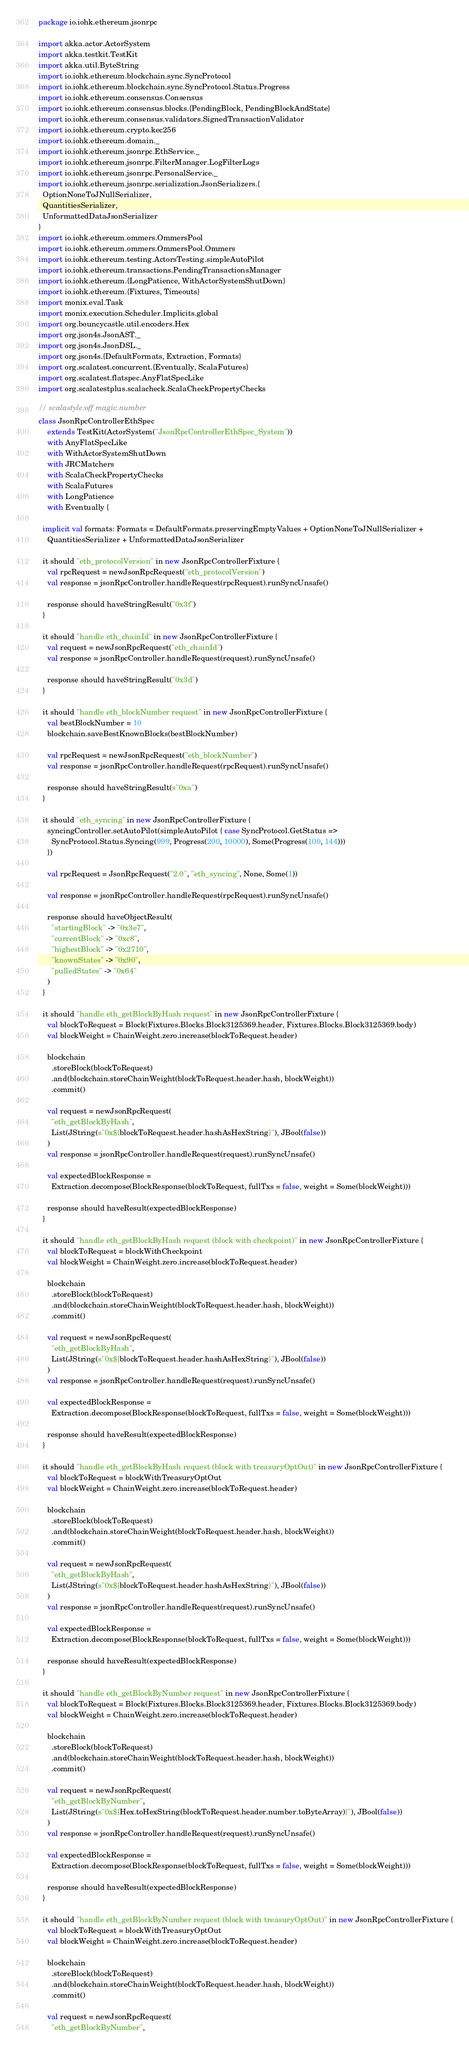<code> <loc_0><loc_0><loc_500><loc_500><_Scala_>package io.iohk.ethereum.jsonrpc

import akka.actor.ActorSystem
import akka.testkit.TestKit
import akka.util.ByteString
import io.iohk.ethereum.blockchain.sync.SyncProtocol
import io.iohk.ethereum.blockchain.sync.SyncProtocol.Status.Progress
import io.iohk.ethereum.consensus.Consensus
import io.iohk.ethereum.consensus.blocks.{PendingBlock, PendingBlockAndState}
import io.iohk.ethereum.consensus.validators.SignedTransactionValidator
import io.iohk.ethereum.crypto.kec256
import io.iohk.ethereum.domain._
import io.iohk.ethereum.jsonrpc.EthService._
import io.iohk.ethereum.jsonrpc.FilterManager.LogFilterLogs
import io.iohk.ethereum.jsonrpc.PersonalService._
import io.iohk.ethereum.jsonrpc.serialization.JsonSerializers.{
  OptionNoneToJNullSerializer,
  QuantitiesSerializer,
  UnformattedDataJsonSerializer
}
import io.iohk.ethereum.ommers.OmmersPool
import io.iohk.ethereum.ommers.OmmersPool.Ommers
import io.iohk.ethereum.testing.ActorsTesting.simpleAutoPilot
import io.iohk.ethereum.transactions.PendingTransactionsManager
import io.iohk.ethereum.{LongPatience, WithActorSystemShutDown}
import io.iohk.ethereum.{Fixtures, Timeouts}
import monix.eval.Task
import monix.execution.Scheduler.Implicits.global
import org.bouncycastle.util.encoders.Hex
import org.json4s.JsonAST._
import org.json4s.JsonDSL._
import org.json4s.{DefaultFormats, Extraction, Formats}
import org.scalatest.concurrent.{Eventually, ScalaFutures}
import org.scalatest.flatspec.AnyFlatSpecLike
import org.scalatestplus.scalacheck.ScalaCheckPropertyChecks

// scalastyle:off magic.number
class JsonRpcControllerEthSpec
    extends TestKit(ActorSystem("JsonRpcControllerEthSpec_System"))
    with AnyFlatSpecLike
    with WithActorSystemShutDown
    with JRCMatchers
    with ScalaCheckPropertyChecks
    with ScalaFutures
    with LongPatience
    with Eventually {

  implicit val formats: Formats = DefaultFormats.preservingEmptyValues + OptionNoneToJNullSerializer +
    QuantitiesSerializer + UnformattedDataJsonSerializer

  it should "eth_protocolVersion" in new JsonRpcControllerFixture {
    val rpcRequest = newJsonRpcRequest("eth_protocolVersion")
    val response = jsonRpcController.handleRequest(rpcRequest).runSyncUnsafe()

    response should haveStringResult("0x3f")
  }

  it should "handle eth_chainId" in new JsonRpcControllerFixture {
    val request = newJsonRpcRequest("eth_chainId")
    val response = jsonRpcController.handleRequest(request).runSyncUnsafe()

    response should haveStringResult("0x3d")
  }

  it should "handle eth_blockNumber request" in new JsonRpcControllerFixture {
    val bestBlockNumber = 10
    blockchain.saveBestKnownBlocks(bestBlockNumber)

    val rpcRequest = newJsonRpcRequest("eth_blockNumber")
    val response = jsonRpcController.handleRequest(rpcRequest).runSyncUnsafe()

    response should haveStringResult(s"0xa")
  }

  it should "eth_syncing" in new JsonRpcControllerFixture {
    syncingController.setAutoPilot(simpleAutoPilot { case SyncProtocol.GetStatus =>
      SyncProtocol.Status.Syncing(999, Progress(200, 10000), Some(Progress(100, 144)))
    })

    val rpcRequest = JsonRpcRequest("2.0", "eth_syncing", None, Some(1))

    val response = jsonRpcController.handleRequest(rpcRequest).runSyncUnsafe()

    response should haveObjectResult(
      "startingBlock" -> "0x3e7",
      "currentBlock" -> "0xc8",
      "highestBlock" -> "0x2710",
      "knownStates" -> "0x90",
      "pulledStates" -> "0x64"
    )
  }

  it should "handle eth_getBlockByHash request" in new JsonRpcControllerFixture {
    val blockToRequest = Block(Fixtures.Blocks.Block3125369.header, Fixtures.Blocks.Block3125369.body)
    val blockWeight = ChainWeight.zero.increase(blockToRequest.header)

    blockchain
      .storeBlock(blockToRequest)
      .and(blockchain.storeChainWeight(blockToRequest.header.hash, blockWeight))
      .commit()

    val request = newJsonRpcRequest(
      "eth_getBlockByHash",
      List(JString(s"0x${blockToRequest.header.hashAsHexString}"), JBool(false))
    )
    val response = jsonRpcController.handleRequest(request).runSyncUnsafe()

    val expectedBlockResponse =
      Extraction.decompose(BlockResponse(blockToRequest, fullTxs = false, weight = Some(blockWeight)))

    response should haveResult(expectedBlockResponse)
  }

  it should "handle eth_getBlockByHash request (block with checkpoint)" in new JsonRpcControllerFixture {
    val blockToRequest = blockWithCheckpoint
    val blockWeight = ChainWeight.zero.increase(blockToRequest.header)

    blockchain
      .storeBlock(blockToRequest)
      .and(blockchain.storeChainWeight(blockToRequest.header.hash, blockWeight))
      .commit()

    val request = newJsonRpcRequest(
      "eth_getBlockByHash",
      List(JString(s"0x${blockToRequest.header.hashAsHexString}"), JBool(false))
    )
    val response = jsonRpcController.handleRequest(request).runSyncUnsafe()

    val expectedBlockResponse =
      Extraction.decompose(BlockResponse(blockToRequest, fullTxs = false, weight = Some(blockWeight)))

    response should haveResult(expectedBlockResponse)
  }

  it should "handle eth_getBlockByHash request (block with treasuryOptOut)" in new JsonRpcControllerFixture {
    val blockToRequest = blockWithTreasuryOptOut
    val blockWeight = ChainWeight.zero.increase(blockToRequest.header)

    blockchain
      .storeBlock(blockToRequest)
      .and(blockchain.storeChainWeight(blockToRequest.header.hash, blockWeight))
      .commit()

    val request = newJsonRpcRequest(
      "eth_getBlockByHash",
      List(JString(s"0x${blockToRequest.header.hashAsHexString}"), JBool(false))
    )
    val response = jsonRpcController.handleRequest(request).runSyncUnsafe()

    val expectedBlockResponse =
      Extraction.decompose(BlockResponse(blockToRequest, fullTxs = false, weight = Some(blockWeight)))

    response should haveResult(expectedBlockResponse)
  }

  it should "handle eth_getBlockByNumber request" in new JsonRpcControllerFixture {
    val blockToRequest = Block(Fixtures.Blocks.Block3125369.header, Fixtures.Blocks.Block3125369.body)
    val blockWeight = ChainWeight.zero.increase(blockToRequest.header)

    blockchain
      .storeBlock(blockToRequest)
      .and(blockchain.storeChainWeight(blockToRequest.header.hash, blockWeight))
      .commit()

    val request = newJsonRpcRequest(
      "eth_getBlockByNumber",
      List(JString(s"0x${Hex.toHexString(blockToRequest.header.number.toByteArray)}"), JBool(false))
    )
    val response = jsonRpcController.handleRequest(request).runSyncUnsafe()

    val expectedBlockResponse =
      Extraction.decompose(BlockResponse(blockToRequest, fullTxs = false, weight = Some(blockWeight)))

    response should haveResult(expectedBlockResponse)
  }

  it should "handle eth_getBlockByNumber request (block with treasuryOptOut)" in new JsonRpcControllerFixture {
    val blockToRequest = blockWithTreasuryOptOut
    val blockWeight = ChainWeight.zero.increase(blockToRequest.header)

    blockchain
      .storeBlock(blockToRequest)
      .and(blockchain.storeChainWeight(blockToRequest.header.hash, blockWeight))
      .commit()

    val request = newJsonRpcRequest(
      "eth_getBlockByNumber",</code> 